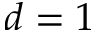<formula> <loc_0><loc_0><loc_500><loc_500>d = 1</formula> 